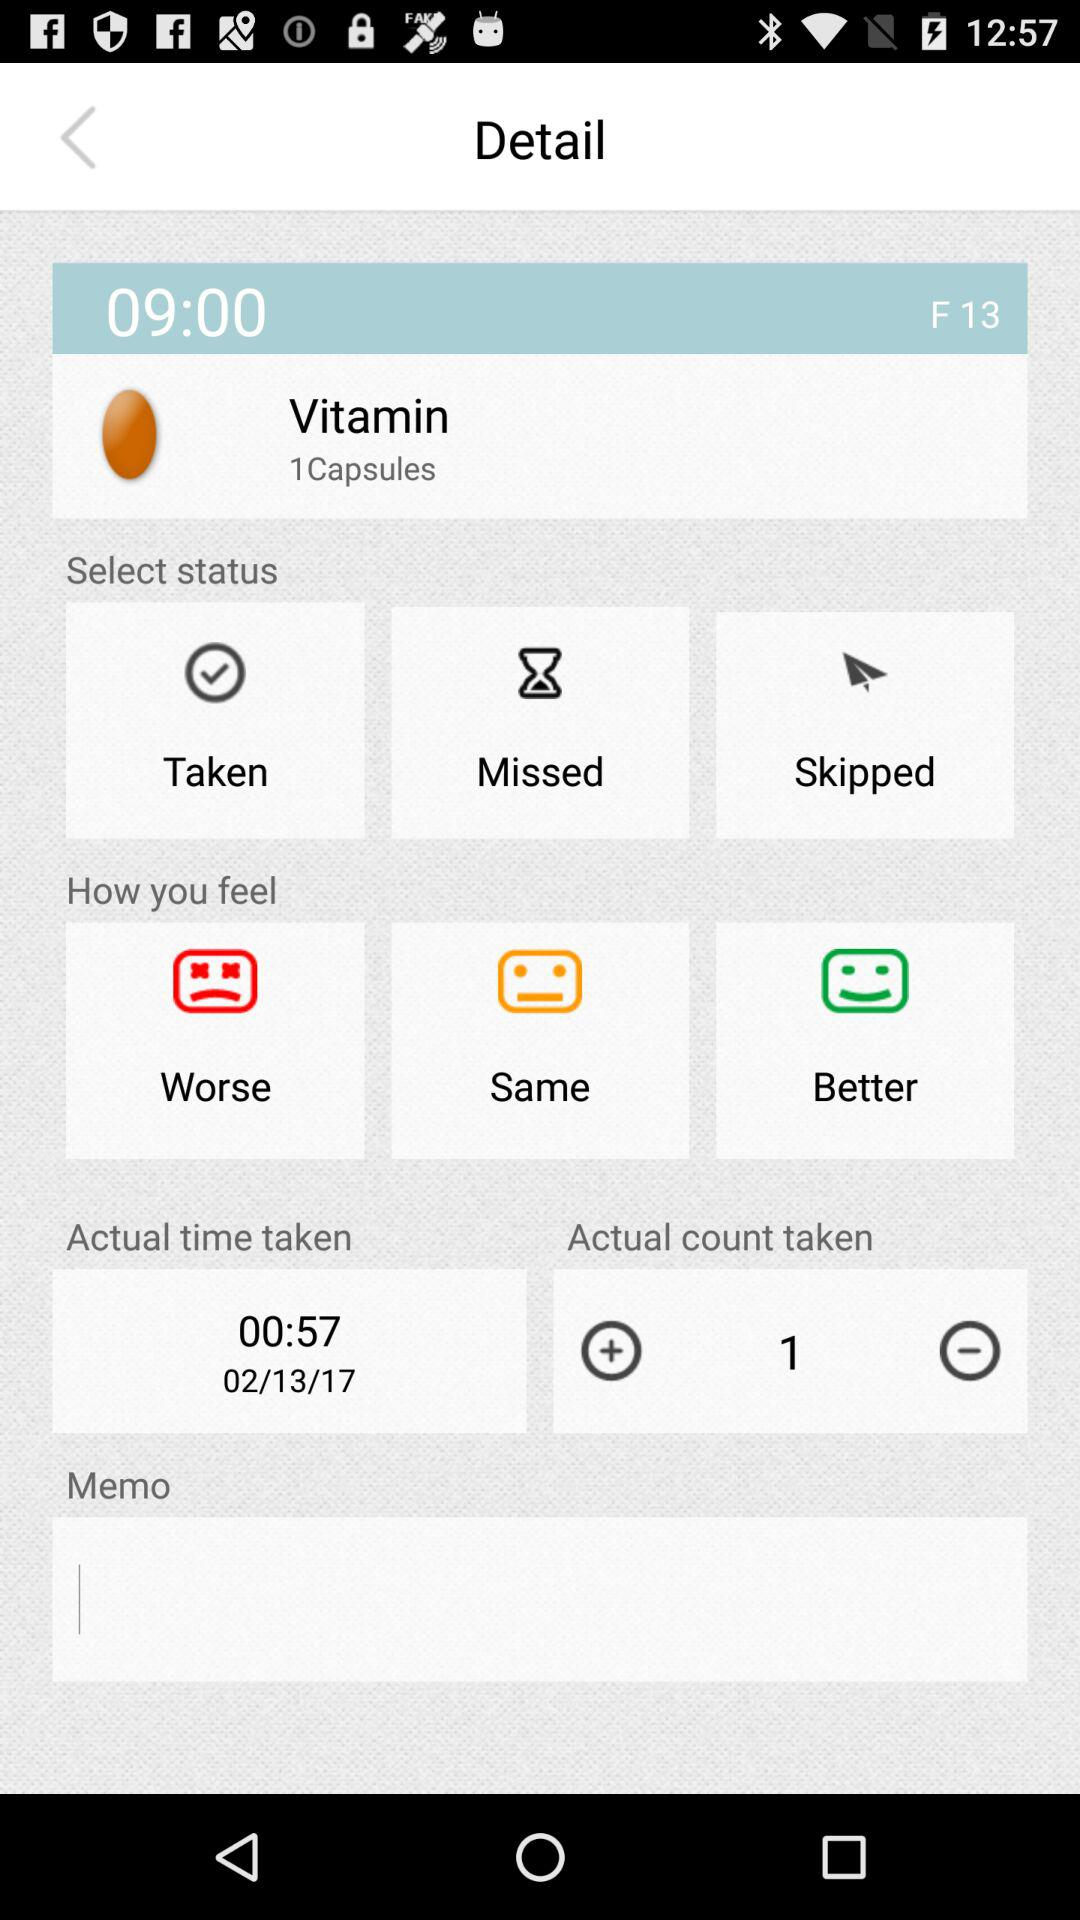How many more times has the user taken this medication than missed it?
Answer the question using a single word or phrase. 1 